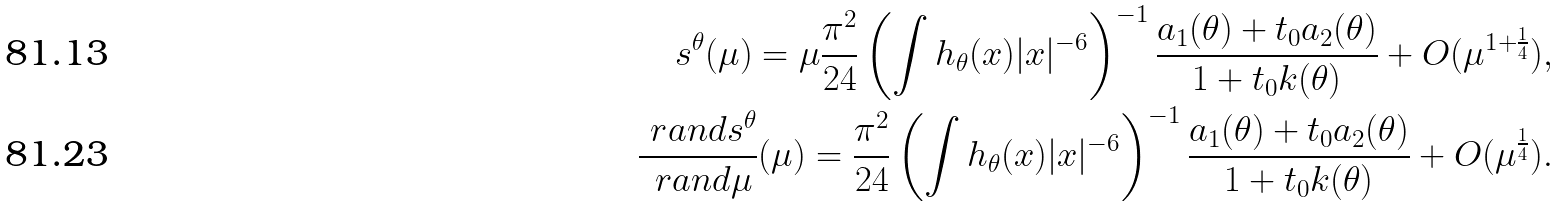<formula> <loc_0><loc_0><loc_500><loc_500>s ^ { \theta } ( \mu ) = \mu \frac { \pi ^ { 2 } } { 2 4 } \left ( \int h _ { \theta } ( x ) | x | ^ { - 6 } \right ) ^ { - 1 } \frac { a _ { 1 } ( \theta ) + t _ { 0 } a _ { 2 } ( \theta ) } { 1 + t _ { 0 } k ( \theta ) } + O ( \mu ^ { 1 + \frac { 1 } { 4 } } ) , \\ \frac { \ r a n d s ^ { \theta } } { \ r a n d \mu } ( \mu ) = \frac { \pi ^ { 2 } } { 2 4 } \left ( \int h _ { \theta } ( x ) | x | ^ { - 6 } \right ) ^ { - 1 } \frac { a _ { 1 } ( \theta ) + t _ { 0 } a _ { 2 } ( \theta ) } { 1 + t _ { 0 } k ( \theta ) } + O ( \mu ^ { \frac { 1 } { 4 } } ) .</formula> 